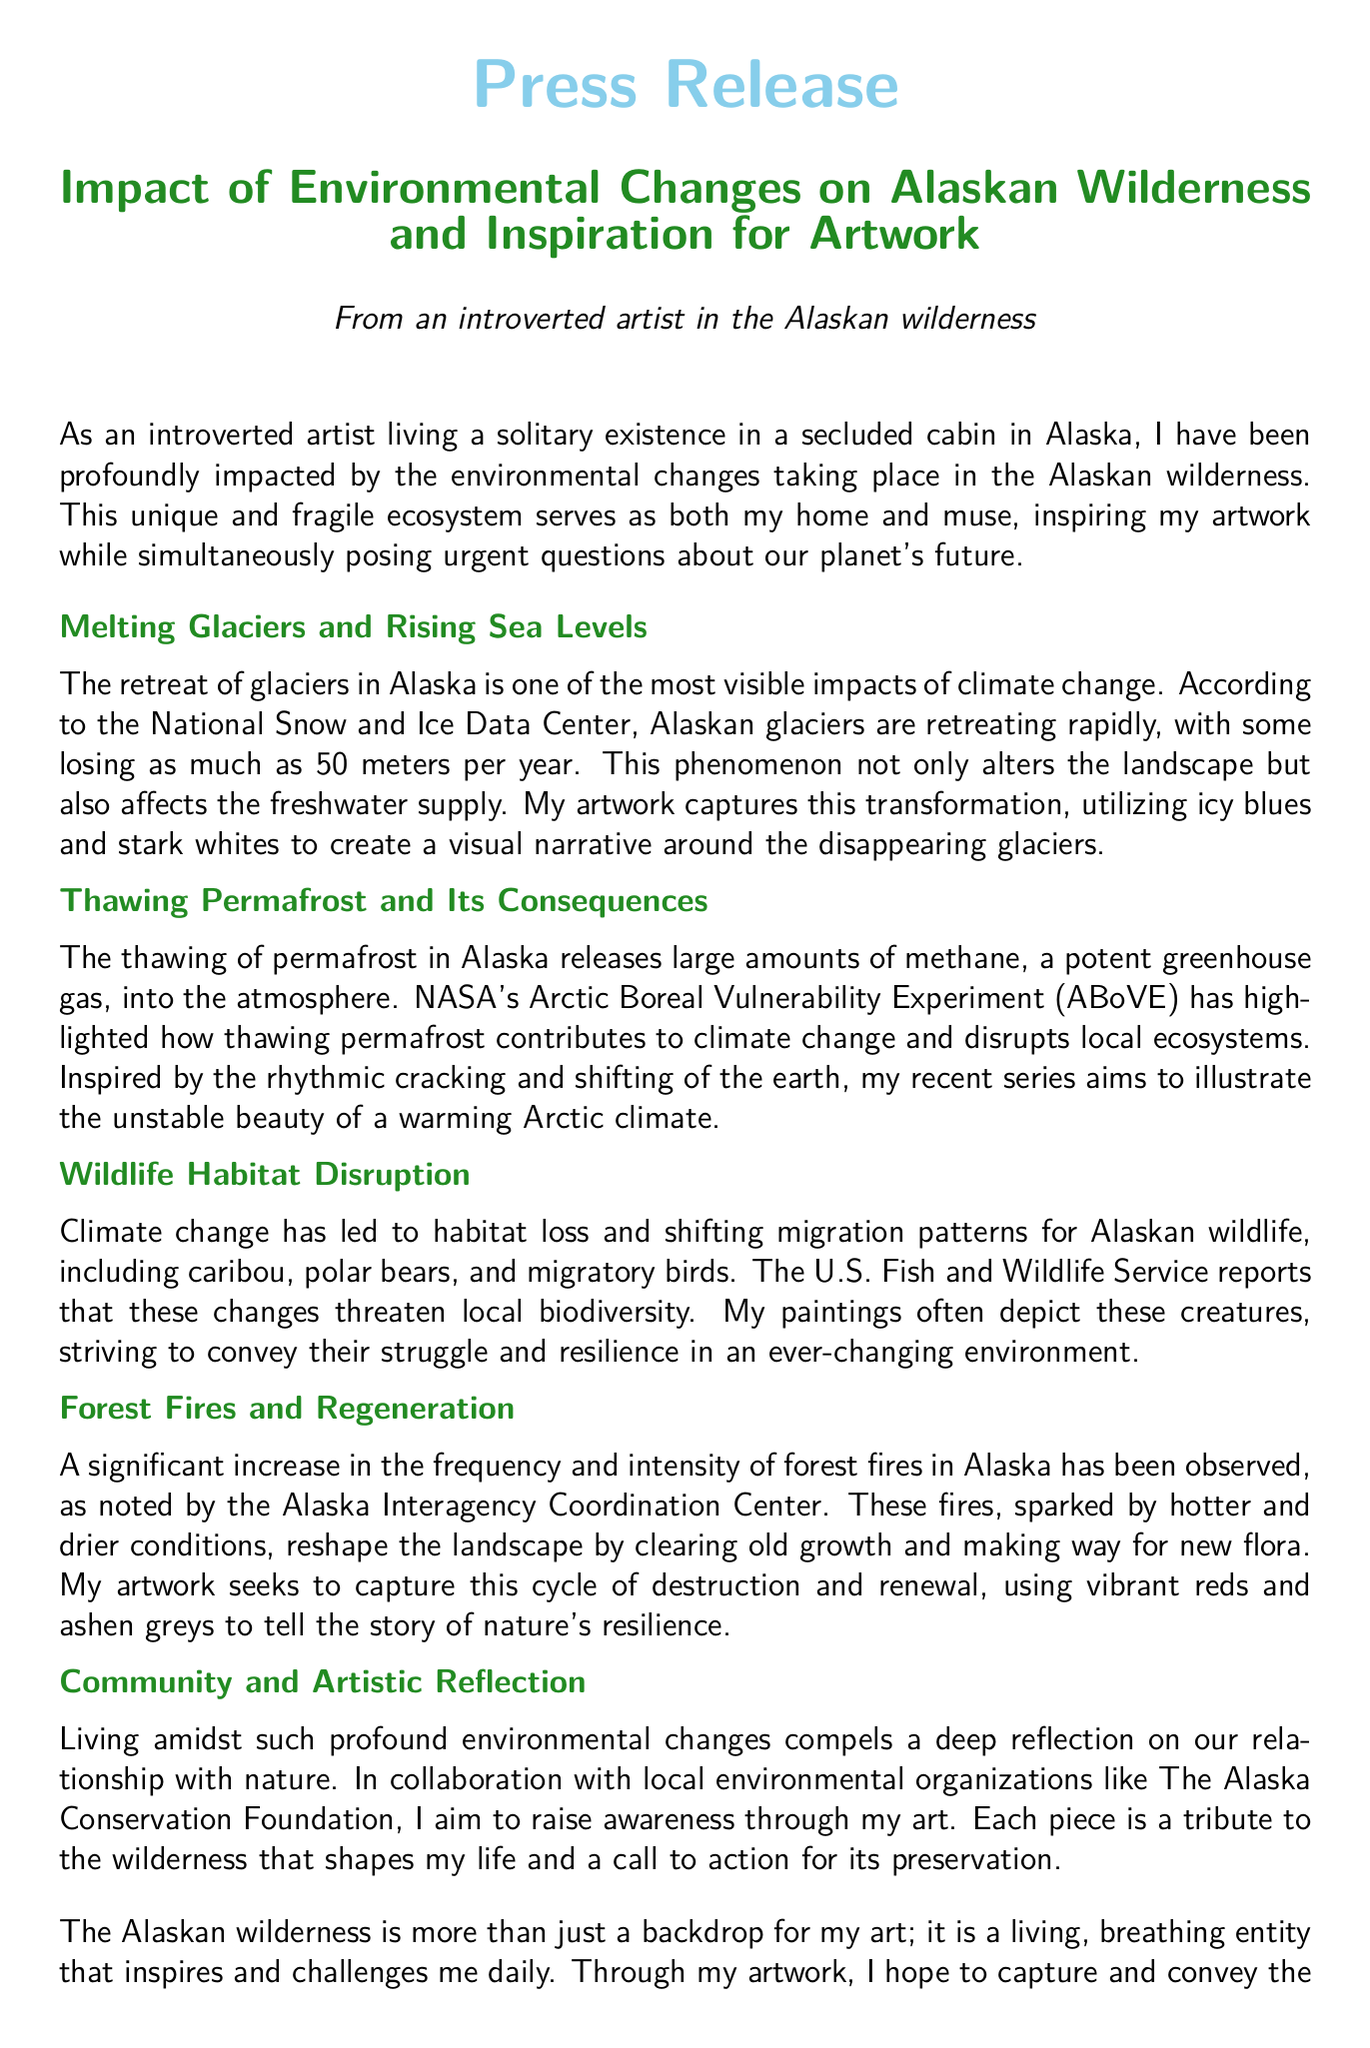What is the title of the press release? The title is specifically stated at the beginning of the document, highlighting the main theme.
Answer: Impact of Environmental Changes on Alaskan Wilderness and Inspiration for Artwork Who reports on the retreat of glaciers? The document cites a specific organization that monitors glaciers, providing credible information.
Answer: National Snow and Ice Data Center What color palette is used in the artwork depicting melting glaciers? The artist describes the use of colors to reflect the transformation of glaciers, stating their choices explicitly.
Answer: Icy blues and stark whites What potent greenhouse gas is released by thawing permafrost? The press release mentions a specific gas released during the permafrost thawing process, a significant environmental concern.
Answer: Methane What increase in frequency is noted regarding forest fires in Alaska? The document states the observed trend of increasing events affecting the landscape, highlighting environmental changes.
Answer: Significant increase Which local organization is mentioned for collaboration in raising environmental awareness? The document includes a key organization involved in community and conservation efforts, emphasizing its role in the artist's mission.
Answer: The Alaska Conservation Foundation What are the main wildlife species affected by climate change? The release specifies certain wildlife that are facing disruption due to environmental shifts, showcasing the impact on biodiversity.
Answer: Caribou, polar bears, and migratory birds What artistic theme is expressed in the response to forest fires? The document describes how the artist interprets and portrays the effects of natural disasters in their work.
Answer: Cycle of destruction and renewal 